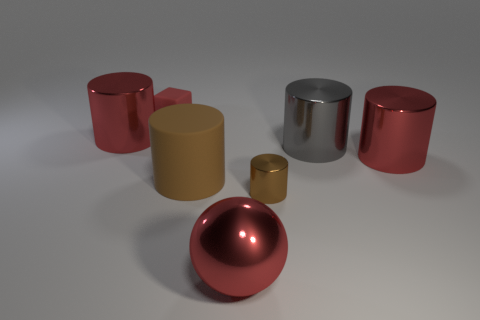Is the material of the big red cylinder that is on the right side of the small red block the same as the large object in front of the large matte cylinder?
Give a very brief answer. Yes. How big is the red metal cylinder that is in front of the red metal cylinder behind the big cylinder that is right of the gray object?
Offer a terse response. Large. What is the material of the sphere that is the same size as the matte cylinder?
Your answer should be compact. Metal. Is there a yellow matte cube of the same size as the red rubber cube?
Ensure brevity in your answer.  No. Is the shape of the tiny brown thing the same as the big gray metal object?
Provide a short and direct response. Yes. Are there any large red metallic objects that are in front of the red cylinder that is right of the large cylinder that is to the left of the small rubber object?
Give a very brief answer. Yes. What number of other objects are the same color as the rubber block?
Your answer should be very brief. 3. There is a shiny cylinder that is on the left side of the block; is it the same size as the red metallic object in front of the small cylinder?
Keep it short and to the point. Yes. Are there the same number of big cylinders that are behind the block and shiny spheres behind the gray cylinder?
Offer a terse response. Yes. Is there anything else that has the same material as the tiny red thing?
Your answer should be very brief. Yes. 